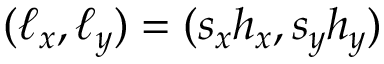<formula> <loc_0><loc_0><loc_500><loc_500>( \ell _ { x } , \ell _ { y } ) = ( s _ { x } h _ { x } , s _ { y } h _ { y } )</formula> 